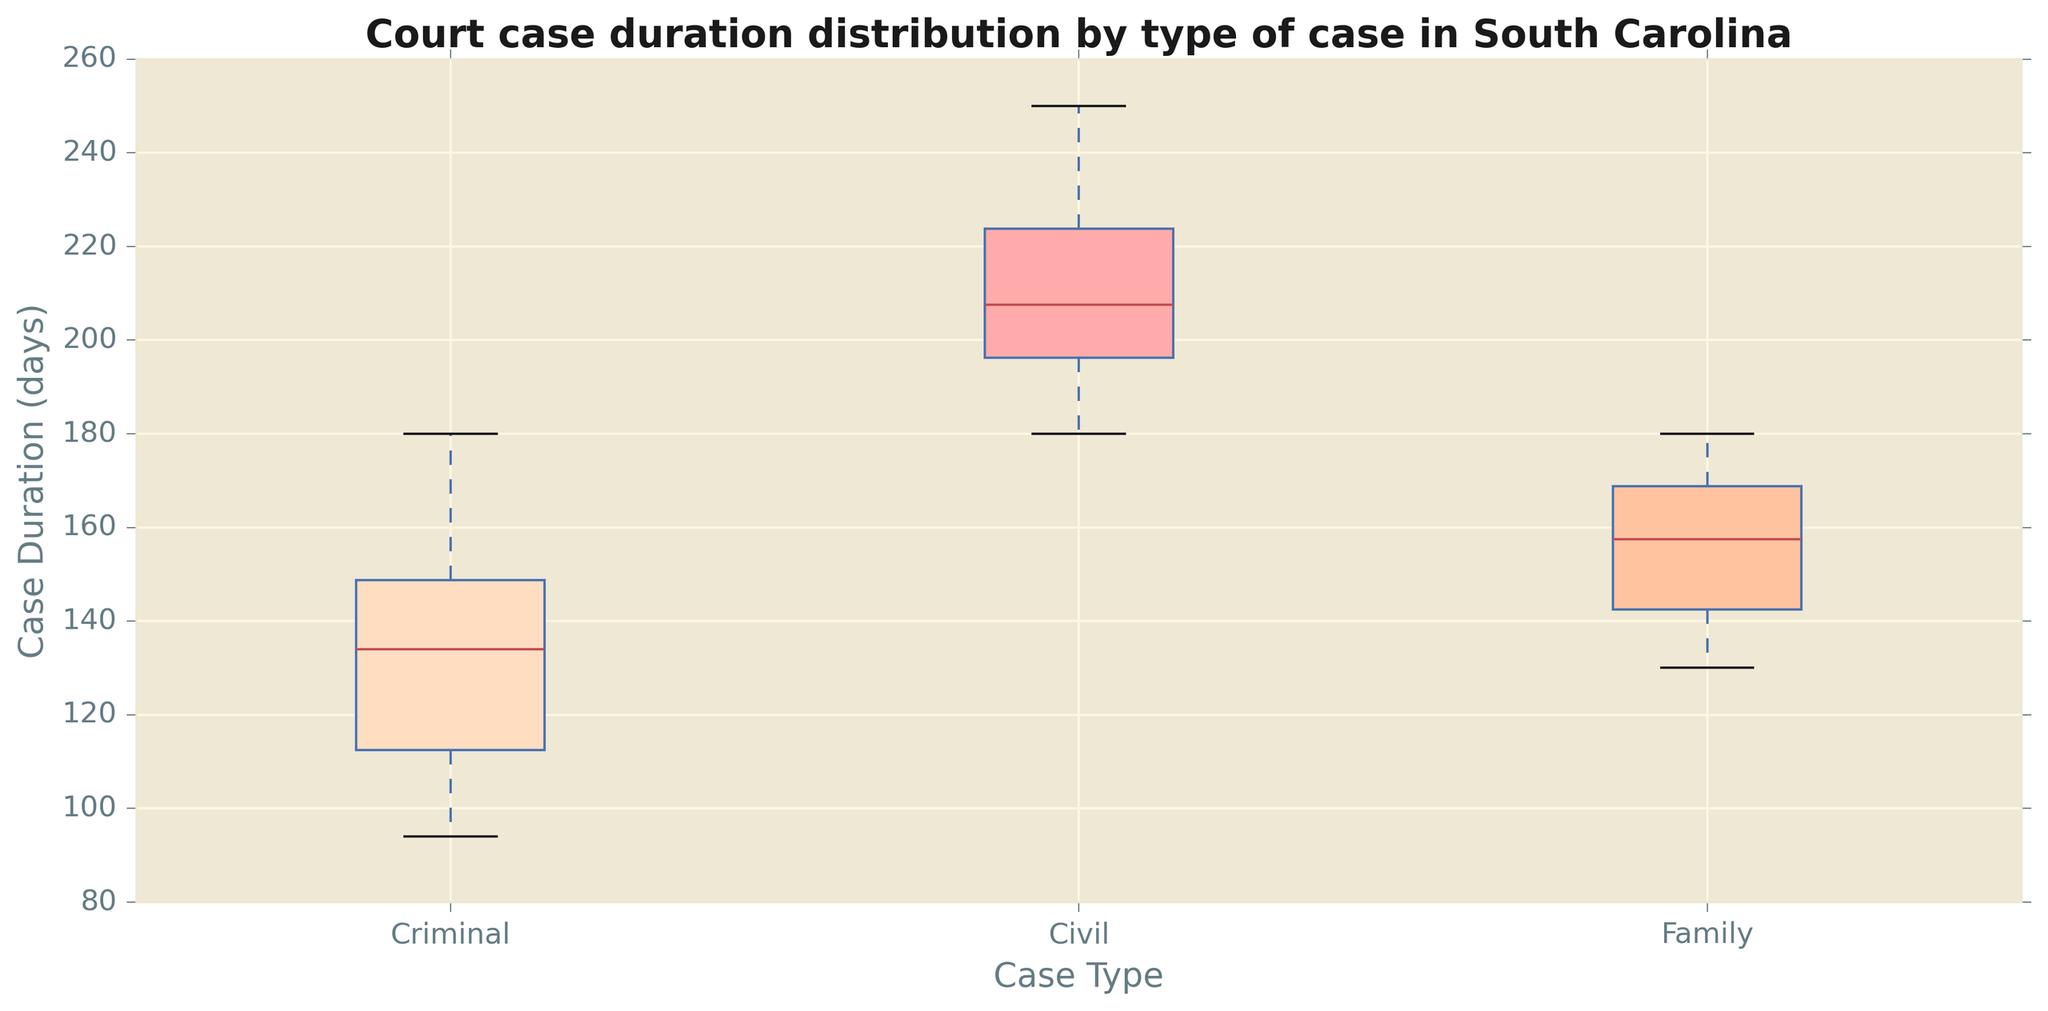Which type of court case has the highest median duration? To determine the median duration, look at the middle line of each box plot. The court case type with the highest median line is the one with the highest median duration.
Answer: Civil How does the variability of civil case durations compare to criminal cases? Variability can be assessed by looking at the height of the box and the length of the whiskers. The box and whiskers for civil cases are taller and longer than those for criminal cases, indicating higher variability.
Answer: Civil cases are more variable Which type of court case has the smallest interquartile range (IQR) for duration? The IQR is represented by the height of the box (distance between the first and third quartiles). The court case type with the smallest box has the smallest IQR.
Answer: Family Are family cases generally shorter or longer in duration compared to criminal cases? Compare the median lines of the family and criminal boxes. The median for family cases is lower than that of criminal cases, indicating shorter durations.
Answer: Shorter Which type of court case has the longest maximum duration? The upper whisker or outlier points represent the maximum duration. The court case type with the highest point or whisker has the longest maximum duration.
Answer: Civil What is the difference between the median durations of criminal and family cases? Locate the median lines of both criminal and family cases. Subtract the median of family cases from the median of criminal cases.
Answer: 15 days Which type of court case has the widest range between the minimum and maximum durations? The range is represented by the distance from the bottom of the lower whisker to the top of the upper whisker or the highest outlier. The type with the longest span has the widest range.
Answer: Civil How does the 75th percentile duration of family cases compare to the 75th percentile of criminal cases? The 75th percentile is represented by the top line of each box. Compare the heights of the top lines for both family and criminal cases.
Answer: Higher in criminal Is there any overlap in the interquartile ranges of all three types of cases? The IQR is the range within the box. If boxes overlap horizontally along the duration axis, there is an overlap in the IQRs.
Answer: Yes 